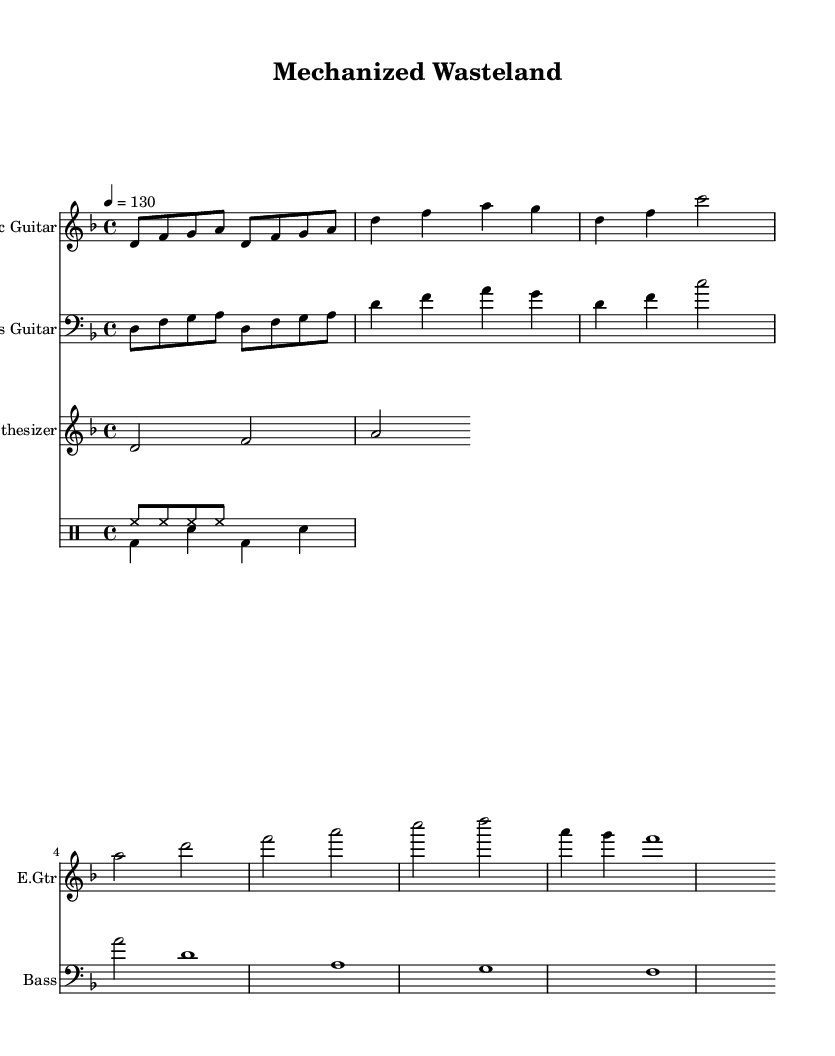What is the key signature of this music? The key signature indicated is D minor, which consists of one flat (B flat). This can be identified at the beginning of the staff where the key signature is displayed.
Answer: D minor What is the time signature of this music? The time signature shown is 4/4, which means there are four beats in each measure and the quarter note receives one beat. This can be seen at the start of the score.
Answer: 4/4 What is the tempo marking for this piece? The tempo marking indicates a speed of quarter note equals 130 beats per minute. This is specified in the tempo section at the beginning of the score.
Answer: 130 How many measures are in the main riff? The main riff is repeated twice, consisting of four eighth notes per repeat, which totals to 8 eighth notes or 2 measures overall. Each repeat is clearly marked in the score.
Answer: 2 Which instrument plays the bridge section? The bridge section is played by the bass guitar, as only that instrument includes a unique section labeled "Bridge" in the part. This can be identified by checking the individual parts shown in the score layout.
Answer: Bass guitar What is the interval of the first note and the second note in the main riff? The first note (D) and the second note (F) create a minor third interval. This is determined by comparing the pitches of D and F, which span three half steps.
Answer: Minor third Which instrument has the lowest pitch in the provided score? The bass guitar has the lowest pitch since it is written in the bass clef, indicating lower notes compared to the other instruments displayed in treble clef. This can be established through the clefs used for each instrument's staff.
Answer: Bass guitar 